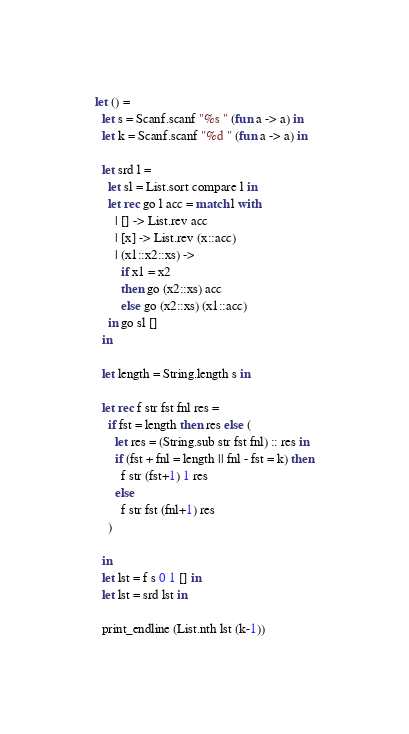<code> <loc_0><loc_0><loc_500><loc_500><_OCaml_>let () =
  let s = Scanf.scanf "%s " (fun a -> a) in
  let k = Scanf.scanf "%d " (fun a -> a) in

  let srd l = 
    let sl = List.sort compare l in
    let rec go l acc = match l with
      | [] -> List.rev acc
      | [x] -> List.rev (x::acc) 
      | (x1::x2::xs) -> 
        if x1 = x2
        then go (x2::xs) acc
        else go (x2::xs) (x1::acc)
    in go sl []
  in

  let length = String.length s in

  let rec f str fst fnl res = 
    if fst = length then res else (
      let res = (String.sub str fst fnl) :: res in
      if (fst + fnl = length || fnl - fst = k) then
        f str (fst+1) 1 res
      else
        f str fst (fnl+1) res
    )

  in
  let lst = f s 0 1 [] in
  let lst = srd lst in

  print_endline (List.nth lst (k-1))

</code> 